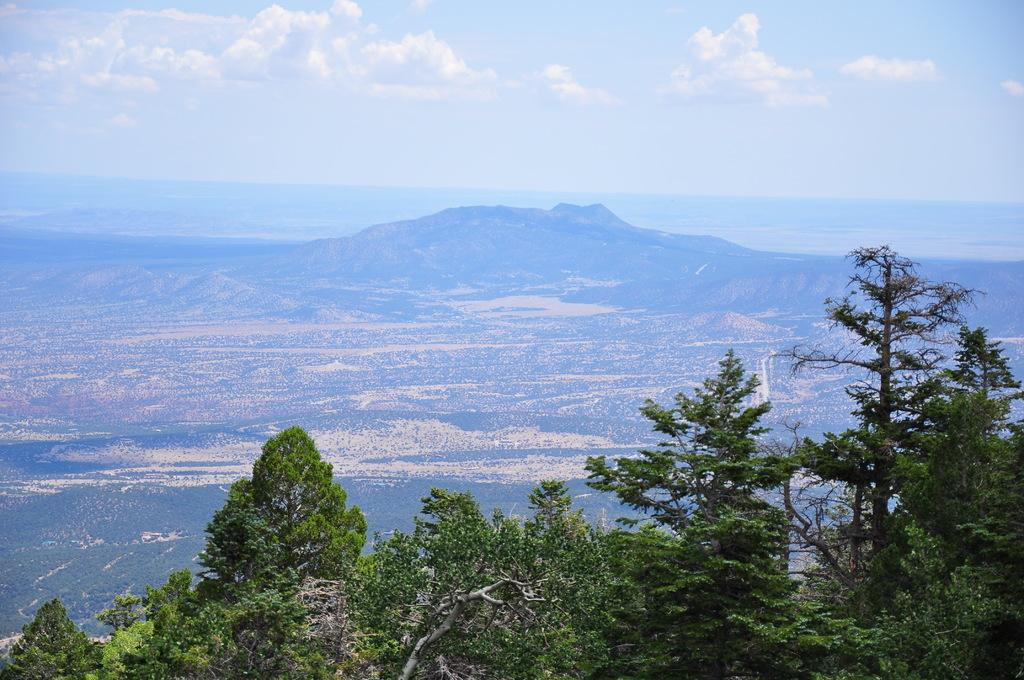What type of vegetation is at the bottom of the image? There are trees at the bottom of the image. What geographical feature is in the middle of the image? There is a mountain in the middle of the image. What is visible at the top of the image? The sky is visible at the top of the image. What can be seen in the sky? Clouds are present in the sky. What is the price of the playground equipment in the image? There is no playground equipment present in the image, so it is not possible to determine its price. 